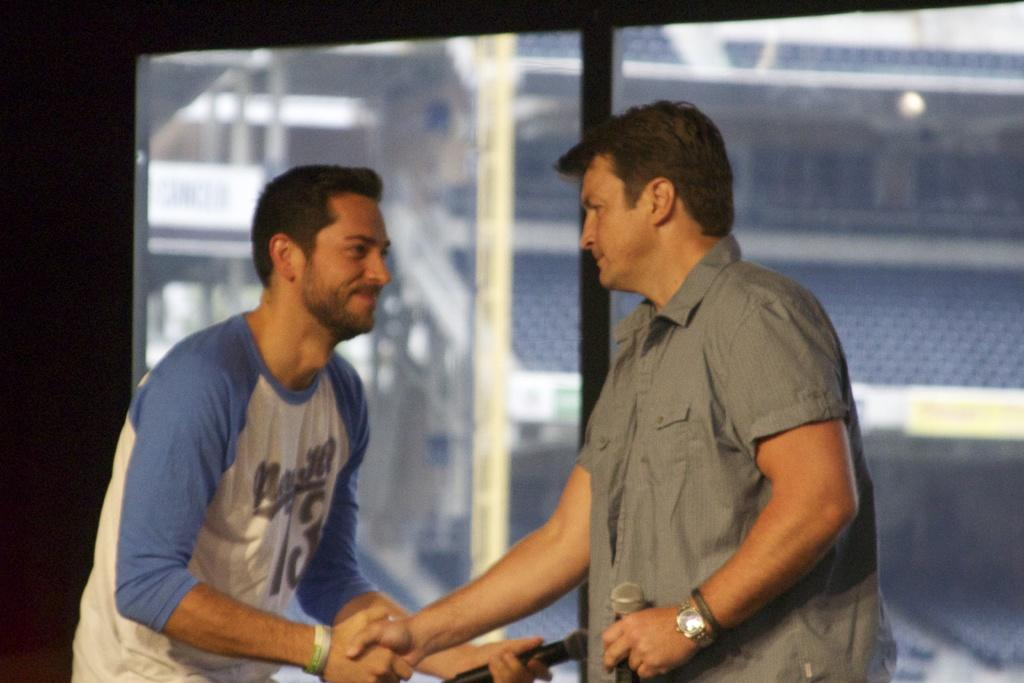How many people are in the image? There are two persons standing in the image. What are the persons holding in their hands? The persons are holding microphones. What can be seen in the background of the image? There is a stadium in the background of the image. What features are present in the stadium? There are poles and chairs in the stadium. What advice does the mother give to the committee in the image? There is no mother or committee present in the image, so it's not possible to answer that question. 